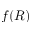<formula> <loc_0><loc_0><loc_500><loc_500>f ( R )</formula> 